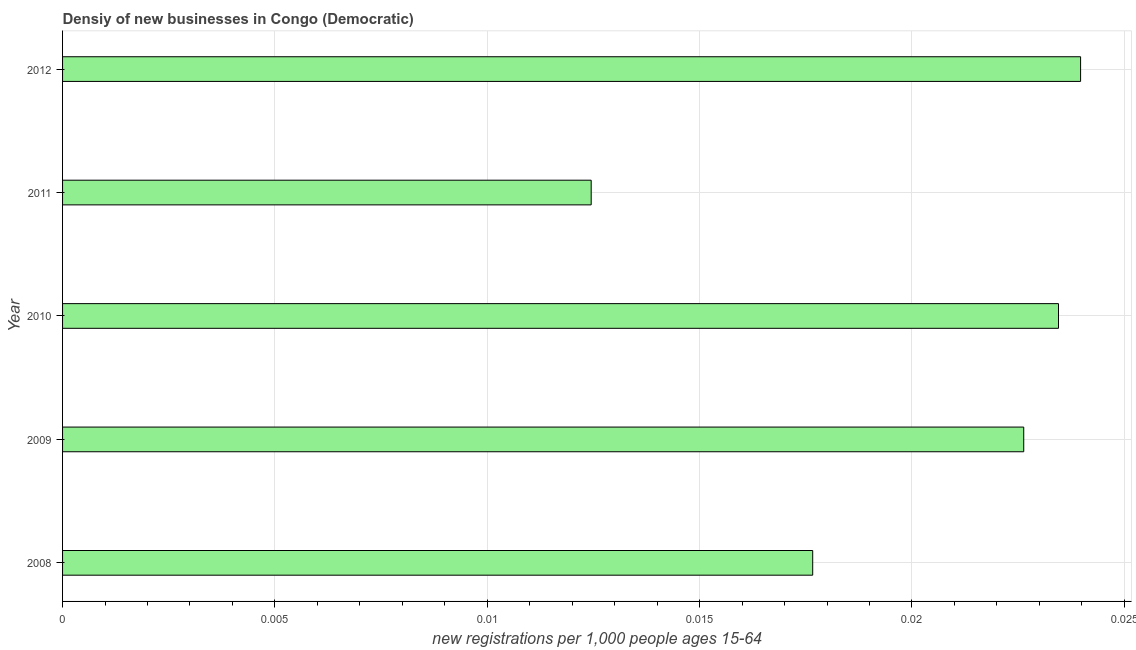Does the graph contain grids?
Your response must be concise. Yes. What is the title of the graph?
Provide a short and direct response. Densiy of new businesses in Congo (Democratic). What is the label or title of the X-axis?
Your answer should be very brief. New registrations per 1,0 people ages 15-64. What is the label or title of the Y-axis?
Provide a short and direct response. Year. What is the density of new business in 2009?
Give a very brief answer. 0.02. Across all years, what is the maximum density of new business?
Your response must be concise. 0.02. Across all years, what is the minimum density of new business?
Offer a very short reply. 0.01. In which year was the density of new business maximum?
Your answer should be very brief. 2012. In which year was the density of new business minimum?
Provide a short and direct response. 2011. What is the sum of the density of new business?
Give a very brief answer. 0.1. What is the difference between the density of new business in 2010 and 2012?
Keep it short and to the point. -0. What is the average density of new business per year?
Provide a succinct answer. 0.02. What is the median density of new business?
Provide a short and direct response. 0.02. What is the ratio of the density of new business in 2009 to that in 2011?
Make the answer very short. 1.82. Is the density of new business in 2008 less than that in 2012?
Ensure brevity in your answer.  Yes. How many years are there in the graph?
Give a very brief answer. 5. What is the difference between two consecutive major ticks on the X-axis?
Give a very brief answer. 0.01. Are the values on the major ticks of X-axis written in scientific E-notation?
Offer a terse response. No. What is the new registrations per 1,000 people ages 15-64 in 2008?
Provide a short and direct response. 0.02. What is the new registrations per 1,000 people ages 15-64 in 2009?
Offer a very short reply. 0.02. What is the new registrations per 1,000 people ages 15-64 in 2010?
Make the answer very short. 0.02. What is the new registrations per 1,000 people ages 15-64 of 2011?
Give a very brief answer. 0.01. What is the new registrations per 1,000 people ages 15-64 of 2012?
Make the answer very short. 0.02. What is the difference between the new registrations per 1,000 people ages 15-64 in 2008 and 2009?
Your answer should be compact. -0. What is the difference between the new registrations per 1,000 people ages 15-64 in 2008 and 2010?
Keep it short and to the point. -0.01. What is the difference between the new registrations per 1,000 people ages 15-64 in 2008 and 2011?
Keep it short and to the point. 0.01. What is the difference between the new registrations per 1,000 people ages 15-64 in 2008 and 2012?
Your response must be concise. -0.01. What is the difference between the new registrations per 1,000 people ages 15-64 in 2009 and 2010?
Offer a very short reply. -0. What is the difference between the new registrations per 1,000 people ages 15-64 in 2009 and 2011?
Your response must be concise. 0.01. What is the difference between the new registrations per 1,000 people ages 15-64 in 2009 and 2012?
Keep it short and to the point. -0. What is the difference between the new registrations per 1,000 people ages 15-64 in 2010 and 2011?
Give a very brief answer. 0.01. What is the difference between the new registrations per 1,000 people ages 15-64 in 2010 and 2012?
Provide a short and direct response. -0. What is the difference between the new registrations per 1,000 people ages 15-64 in 2011 and 2012?
Your response must be concise. -0.01. What is the ratio of the new registrations per 1,000 people ages 15-64 in 2008 to that in 2009?
Keep it short and to the point. 0.78. What is the ratio of the new registrations per 1,000 people ages 15-64 in 2008 to that in 2010?
Give a very brief answer. 0.75. What is the ratio of the new registrations per 1,000 people ages 15-64 in 2008 to that in 2011?
Offer a terse response. 1.42. What is the ratio of the new registrations per 1,000 people ages 15-64 in 2008 to that in 2012?
Your answer should be compact. 0.74. What is the ratio of the new registrations per 1,000 people ages 15-64 in 2009 to that in 2010?
Offer a terse response. 0.96. What is the ratio of the new registrations per 1,000 people ages 15-64 in 2009 to that in 2011?
Offer a very short reply. 1.82. What is the ratio of the new registrations per 1,000 people ages 15-64 in 2009 to that in 2012?
Make the answer very short. 0.94. What is the ratio of the new registrations per 1,000 people ages 15-64 in 2010 to that in 2011?
Offer a very short reply. 1.88. What is the ratio of the new registrations per 1,000 people ages 15-64 in 2010 to that in 2012?
Offer a very short reply. 0.98. What is the ratio of the new registrations per 1,000 people ages 15-64 in 2011 to that in 2012?
Provide a short and direct response. 0.52. 